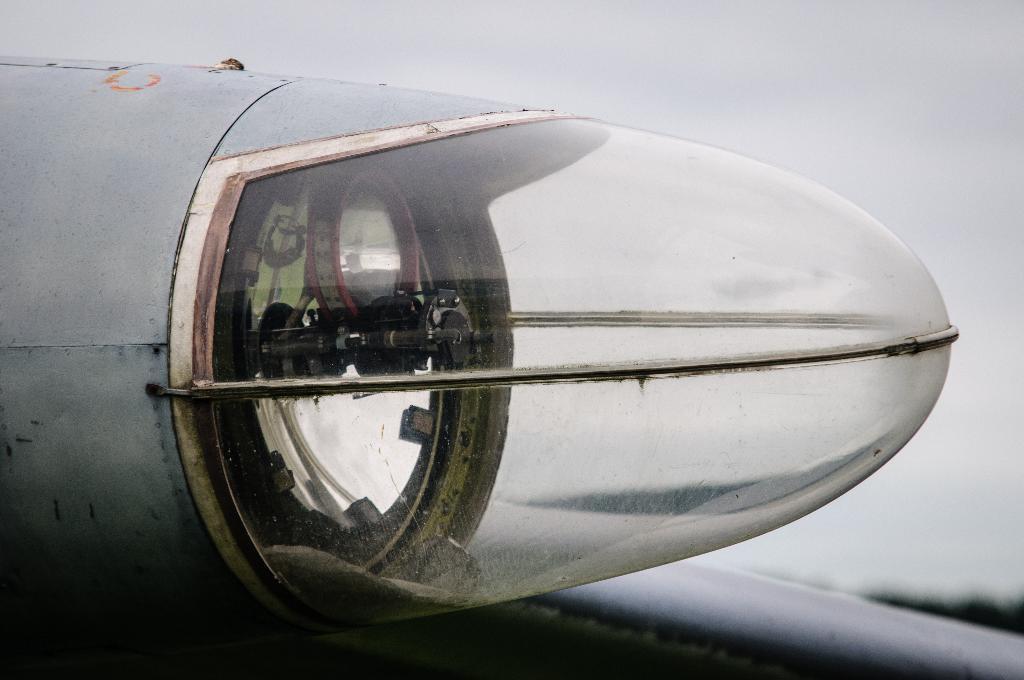Please provide a concise description of this image. In this image I can see a light of an aeroplane. There is sky at the top. 